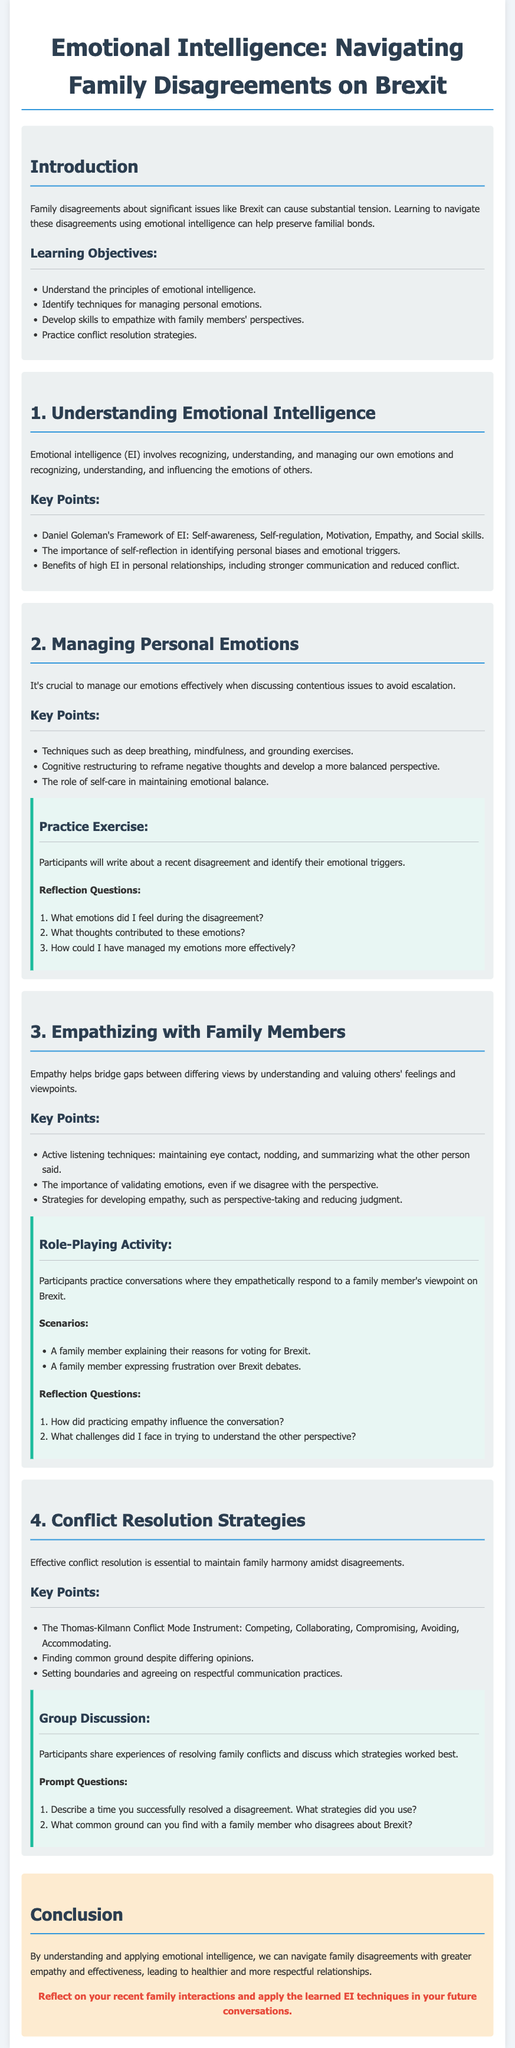what is the title of the lesson plan? The title is given at the top of the document and indicates the main focus of the lesson.
Answer: Emotional Intelligence: Navigating Family Disagreements on Brexit what are the learning objectives? The learning objectives are listed under a specific section and detail what participants will learn.
Answer: Understand the principles of emotional intelligence, Identify techniques for managing personal emotions, Develop skills to empathize with family members' perspectives, Practice conflict resolution strategies who is the author of the Emotional Intelligence framework mentioned? The author of the EI framework is specified in the section discussing emotional intelligence concepts.
Answer: Daniel Goleman what techniques are suggested for managing personal emotions? The document outlines specific techniques in the section about managing emotions effectively.
Answer: Deep breathing, mindfulness, and grounding exercises what is the importance of validating emotions in family discussions? This point is made in the section regarding empathy and is essential for improving understanding between differing views.
Answer: Even if we disagree with the perspective what should participants reflect on during the practice exercise? The reflection questions in the activity guide what participants should consider after writing about their disagreements.
Answer: What emotions did I feel during the disagreement, What thoughts contributed to these emotions, How could I have managed my emotions more effectively which conflict resolution strategy focuses on collaboration? The document lists different conflict modes, one of which specifically emphasizes working together.
Answer: Collaborating what does the conclusion emphasize regarding emotional intelligence? The conclusion summarizes the main takeaway from the lessons learned throughout the document.
Answer: Navigate family disagreements with greater empathy and effectiveness what type of activity is used to practice empathy with family members? The document details an interactive activity that involves role-playing scenarios for better understanding.
Answer: Role-Playing Activity 